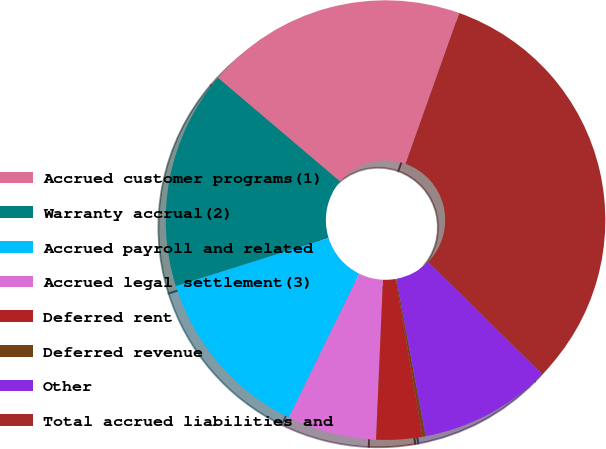Convert chart. <chart><loc_0><loc_0><loc_500><loc_500><pie_chart><fcel>Accrued customer programs(1)<fcel>Warranty accrual(2)<fcel>Accrued payroll and related<fcel>Accrued legal settlement(3)<fcel>Deferred rent<fcel>Deferred revenue<fcel>Other<fcel>Total accrued liabilities and<nl><fcel>19.24%<fcel>16.07%<fcel>12.9%<fcel>6.56%<fcel>3.39%<fcel>0.22%<fcel>9.73%<fcel>31.92%<nl></chart> 